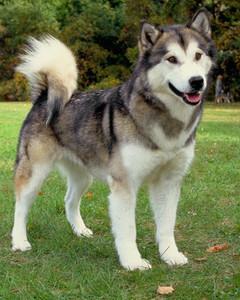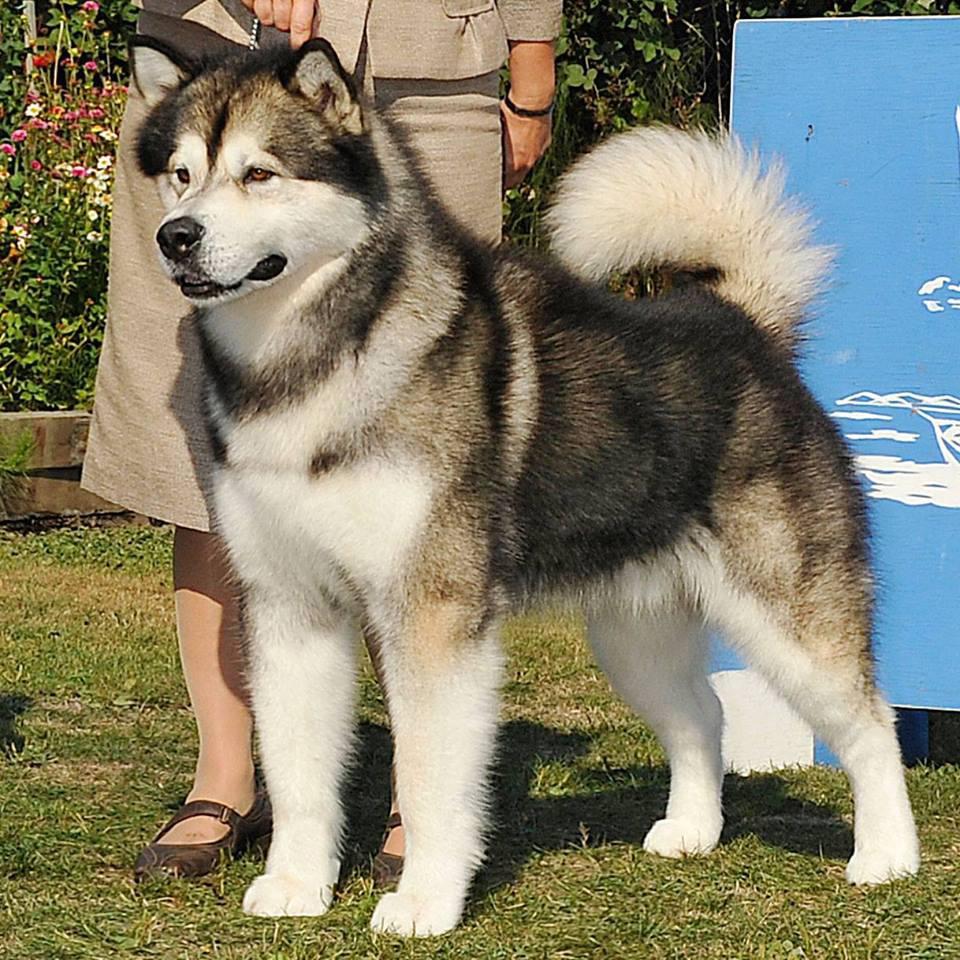The first image is the image on the left, the second image is the image on the right. Analyze the images presented: Is the assertion "The image on the right shows a left-facing dog standing in front of its owner." valid? Answer yes or no. Yes. The first image is the image on the left, the second image is the image on the right. Evaluate the accuracy of this statement regarding the images: "All dogs are huskies with dark-and-white fur who are standing in profile, and the dogs on the left and right do not face the same [left or right] direction.". Is it true? Answer yes or no. Yes. 